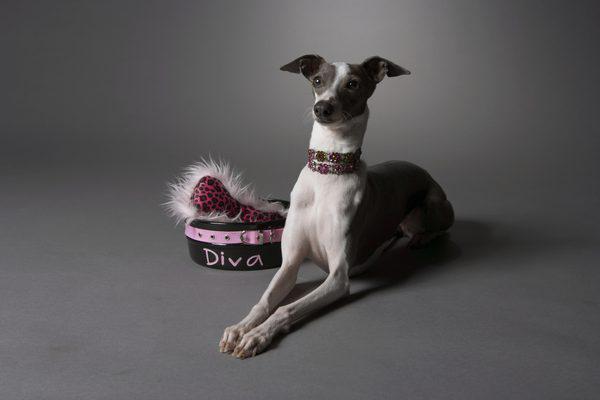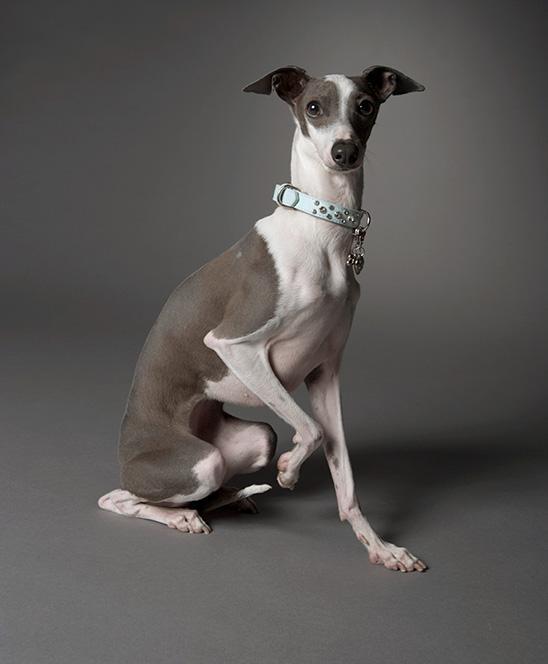The first image is the image on the left, the second image is the image on the right. For the images displayed, is the sentence "At least one image in the pair contains a dog standing up with all four legs on the ground." factually correct? Answer yes or no. No. The first image is the image on the left, the second image is the image on the right. Analyze the images presented: Is the assertion "The dog in one of the images is holding one paw up." valid? Answer yes or no. Yes. 